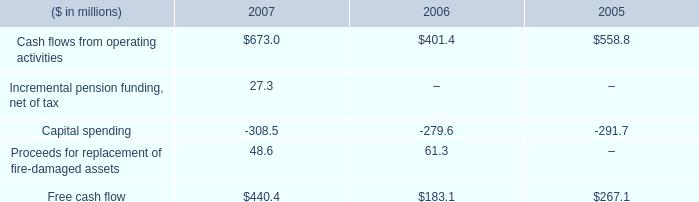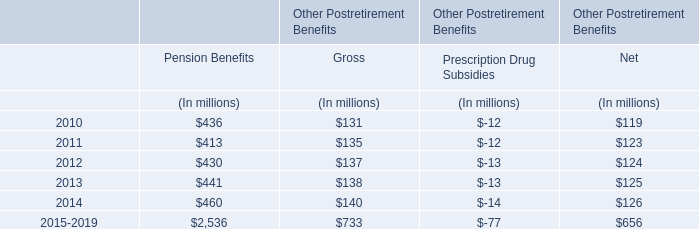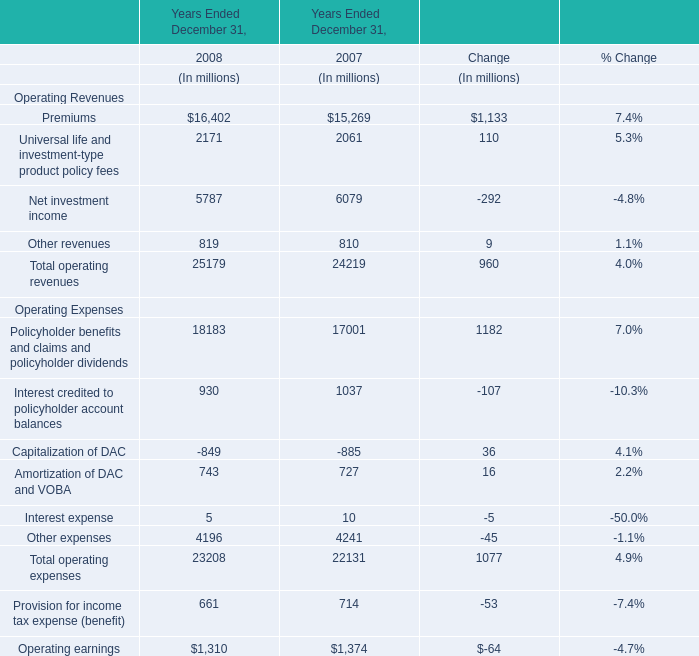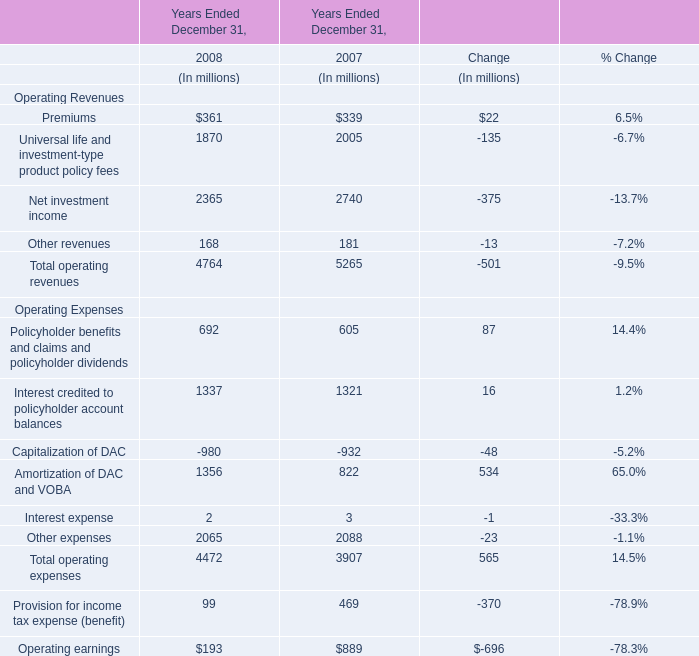What is the growing rate of Total operating expenses in the year with more Total operating revenues? 
Computations: ((23208 - 22131) / 22131)
Answer: 0.04866. 